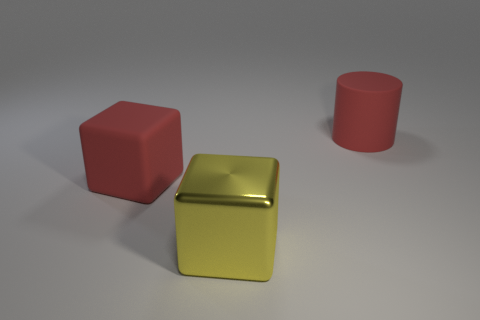Add 3 large cylinders. How many objects exist? 6 Subtract all cylinders. How many objects are left? 2 Subtract 0 cyan cylinders. How many objects are left? 3 Subtract all large cubes. Subtract all metallic things. How many objects are left? 0 Add 3 red rubber cylinders. How many red rubber cylinders are left? 4 Add 1 purple rubber spheres. How many purple rubber spheres exist? 1 